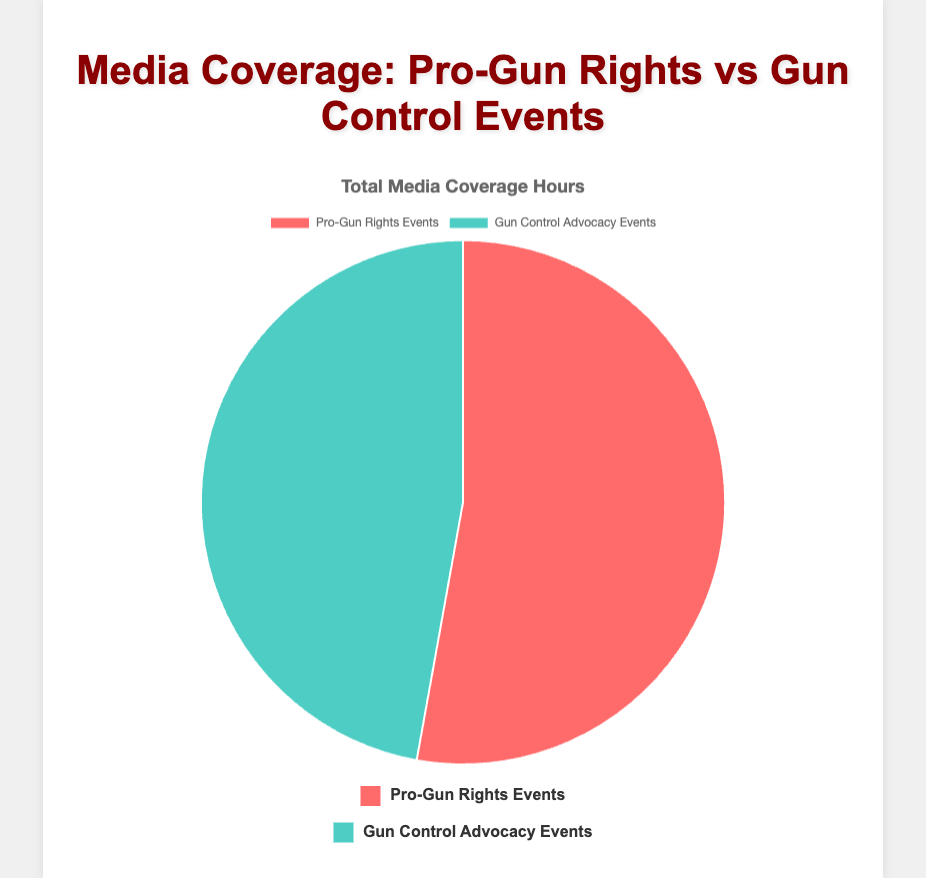What is the total media coverage for pro-gun rights events? The total media coverage for pro-gun rights events can be derived from the pie chart data. According to the provided data, the total media coverage is 140 hours.
Answer: 140 hours Which event type has more media coverage hours? By comparing the pie chart segments, we can see that pro-gun rights events have larger colored segment compared to gun control advocacy events, indicating more media coverage hours for pro-gun rights.
Answer: Pro-gun rights events What is the combined media coverage for CNN for both event types? CNN coverage for pro-gun rights events is 20 hours and for gun control advocacy events is 45 hours. Summing them: 20 + 45 = 65 hours.
Answer: 65 hours How much more coverage does Fox News provide to pro-gun rights events compared to gun control advocacy events? Fox News provides 50 hours for pro-gun rights events and 15 hours for gun control advocacy events. The difference is: 50 - 15 = 35 hours.
Answer: 35 hours What is the total media coverage for The Blaze across both event types? The Blaze provides 30 hours for pro-gun rights events and 5 hours for gun control advocacy events. The total coverage is: 30 + 5 = 35 hours.
Answer: 35 hours 